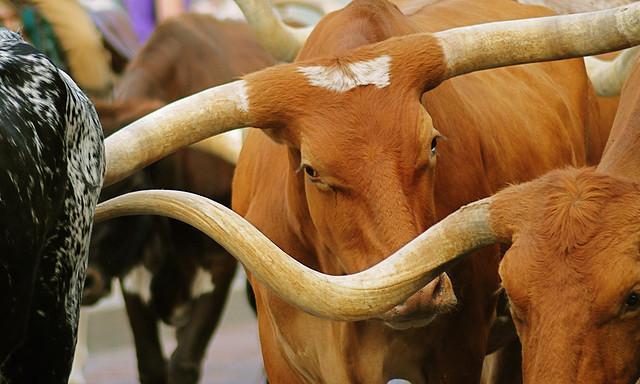What are long horn cows called?
Choose the right answer from the provided options to respond to the question.
Options: Extended horn, horne, horner, longhorn cattle. Longhorn cattle. 